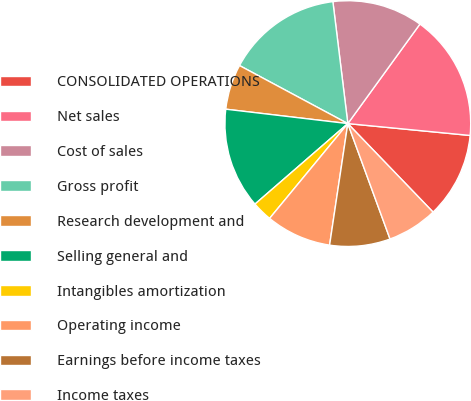<chart> <loc_0><loc_0><loc_500><loc_500><pie_chart><fcel>CONSOLIDATED OPERATIONS<fcel>Net sales<fcel>Cost of sales<fcel>Gross profit<fcel>Research development and<fcel>Selling general and<fcel>Intangibles amortization<fcel>Operating income<fcel>Earnings before income taxes<fcel>Income taxes<nl><fcel>11.26%<fcel>16.56%<fcel>11.92%<fcel>15.23%<fcel>5.96%<fcel>13.24%<fcel>2.65%<fcel>8.61%<fcel>7.95%<fcel>6.62%<nl></chart> 